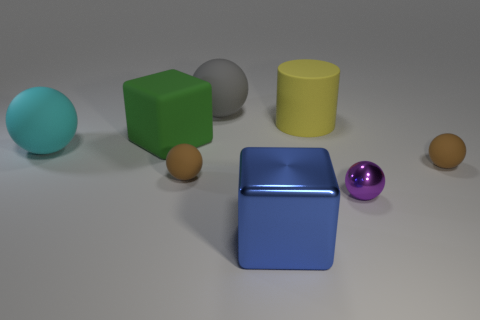Subtract all cyan spheres. How many spheres are left? 4 Subtract all blue blocks. How many brown balls are left? 2 Subtract all cyan balls. How many balls are left? 4 Subtract all cylinders. How many objects are left? 7 Add 2 large cyan rubber things. How many objects exist? 10 Subtract all green balls. Subtract all yellow cylinders. How many balls are left? 5 Add 4 big metal blocks. How many big metal blocks exist? 5 Subtract 1 yellow cylinders. How many objects are left? 7 Subtract all purple shiny objects. Subtract all cyan rubber objects. How many objects are left? 6 Add 7 small purple things. How many small purple things are left? 8 